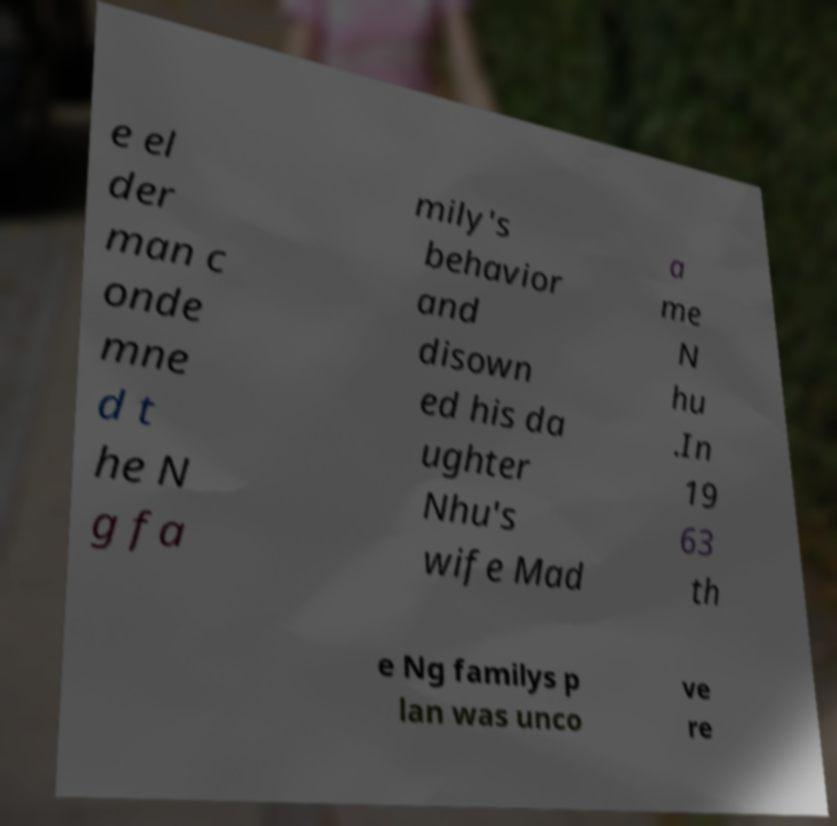Could you assist in decoding the text presented in this image and type it out clearly? e el der man c onde mne d t he N g fa mily's behavior and disown ed his da ughter Nhu's wife Mad a me N hu .In 19 63 th e Ng familys p lan was unco ve re 